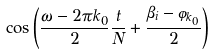<formula> <loc_0><loc_0><loc_500><loc_500>\cos \left ( \frac { \omega - 2 \pi k _ { 0 } } { 2 } \frac { t } { N } + \frac { \beta _ { i } - \varphi _ { k _ { 0 } } } { 2 } \right )</formula> 